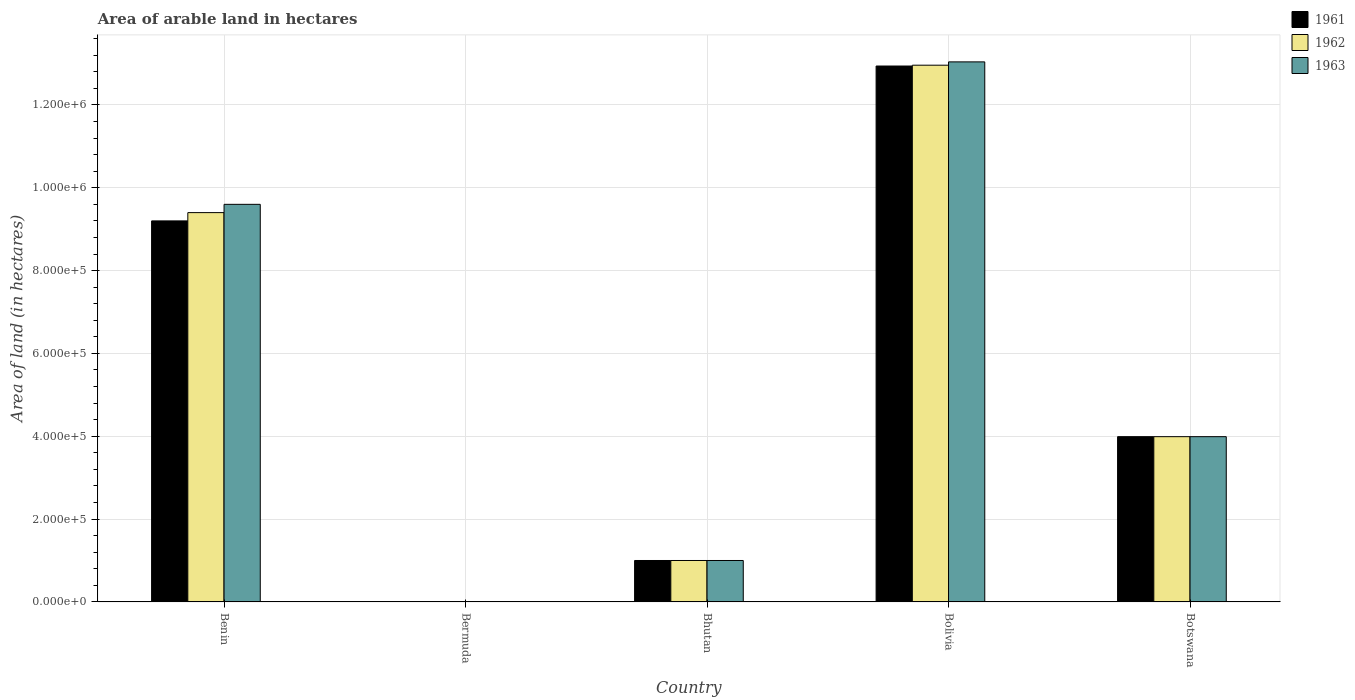How many different coloured bars are there?
Your answer should be compact. 3. How many groups of bars are there?
Make the answer very short. 5. Are the number of bars per tick equal to the number of legend labels?
Provide a short and direct response. Yes. Are the number of bars on each tick of the X-axis equal?
Your response must be concise. Yes. How many bars are there on the 1st tick from the left?
Your answer should be very brief. 3. What is the label of the 2nd group of bars from the left?
Give a very brief answer. Bermuda. In how many cases, is the number of bars for a given country not equal to the number of legend labels?
Keep it short and to the point. 0. What is the total arable land in 1963 in Bermuda?
Your response must be concise. 300. Across all countries, what is the maximum total arable land in 1961?
Offer a very short reply. 1.29e+06. In which country was the total arable land in 1962 maximum?
Offer a terse response. Bolivia. In which country was the total arable land in 1961 minimum?
Make the answer very short. Bermuda. What is the total total arable land in 1963 in the graph?
Provide a succinct answer. 2.76e+06. What is the difference between the total arable land in 1961 in Bhutan and that in Bolivia?
Ensure brevity in your answer.  -1.19e+06. What is the difference between the total arable land in 1962 in Bermuda and the total arable land in 1961 in Bolivia?
Ensure brevity in your answer.  -1.29e+06. What is the average total arable land in 1963 per country?
Provide a succinct answer. 5.53e+05. What is the difference between the total arable land of/in 1961 and total arable land of/in 1962 in Botswana?
Your answer should be very brief. 0. In how many countries, is the total arable land in 1963 greater than 1080000 hectares?
Give a very brief answer. 1. What is the ratio of the total arable land in 1963 in Bhutan to that in Bolivia?
Your response must be concise. 0.08. Is the total arable land in 1961 in Benin less than that in Bhutan?
Ensure brevity in your answer.  No. What is the difference between the highest and the second highest total arable land in 1963?
Ensure brevity in your answer.  3.44e+05. What is the difference between the highest and the lowest total arable land in 1962?
Your answer should be compact. 1.30e+06. What does the 3rd bar from the left in Bermuda represents?
Your response must be concise. 1963. What does the 3rd bar from the right in Bolivia represents?
Your response must be concise. 1961. Is it the case that in every country, the sum of the total arable land in 1962 and total arable land in 1961 is greater than the total arable land in 1963?
Your answer should be very brief. Yes. How many bars are there?
Your answer should be compact. 15. What is the difference between two consecutive major ticks on the Y-axis?
Your answer should be very brief. 2.00e+05. Does the graph contain grids?
Your answer should be compact. Yes. Where does the legend appear in the graph?
Give a very brief answer. Top right. What is the title of the graph?
Offer a terse response. Area of arable land in hectares. Does "2011" appear as one of the legend labels in the graph?
Ensure brevity in your answer.  No. What is the label or title of the Y-axis?
Offer a very short reply. Area of land (in hectares). What is the Area of land (in hectares) in 1961 in Benin?
Provide a short and direct response. 9.20e+05. What is the Area of land (in hectares) in 1962 in Benin?
Your response must be concise. 9.40e+05. What is the Area of land (in hectares) of 1963 in Benin?
Your response must be concise. 9.60e+05. What is the Area of land (in hectares) in 1962 in Bermuda?
Your answer should be very brief. 300. What is the Area of land (in hectares) of 1963 in Bermuda?
Your answer should be compact. 300. What is the Area of land (in hectares) of 1962 in Bhutan?
Keep it short and to the point. 1.00e+05. What is the Area of land (in hectares) of 1961 in Bolivia?
Keep it short and to the point. 1.29e+06. What is the Area of land (in hectares) in 1962 in Bolivia?
Make the answer very short. 1.30e+06. What is the Area of land (in hectares) in 1963 in Bolivia?
Make the answer very short. 1.30e+06. What is the Area of land (in hectares) of 1961 in Botswana?
Keep it short and to the point. 3.99e+05. What is the Area of land (in hectares) of 1962 in Botswana?
Keep it short and to the point. 3.99e+05. What is the Area of land (in hectares) of 1963 in Botswana?
Your answer should be very brief. 3.99e+05. Across all countries, what is the maximum Area of land (in hectares) in 1961?
Provide a short and direct response. 1.29e+06. Across all countries, what is the maximum Area of land (in hectares) of 1962?
Your response must be concise. 1.30e+06. Across all countries, what is the maximum Area of land (in hectares) in 1963?
Provide a short and direct response. 1.30e+06. Across all countries, what is the minimum Area of land (in hectares) in 1962?
Keep it short and to the point. 300. Across all countries, what is the minimum Area of land (in hectares) of 1963?
Provide a succinct answer. 300. What is the total Area of land (in hectares) in 1961 in the graph?
Ensure brevity in your answer.  2.71e+06. What is the total Area of land (in hectares) of 1962 in the graph?
Give a very brief answer. 2.74e+06. What is the total Area of land (in hectares) of 1963 in the graph?
Offer a very short reply. 2.76e+06. What is the difference between the Area of land (in hectares) in 1961 in Benin and that in Bermuda?
Make the answer very short. 9.20e+05. What is the difference between the Area of land (in hectares) of 1962 in Benin and that in Bermuda?
Provide a short and direct response. 9.40e+05. What is the difference between the Area of land (in hectares) in 1963 in Benin and that in Bermuda?
Provide a short and direct response. 9.60e+05. What is the difference between the Area of land (in hectares) in 1961 in Benin and that in Bhutan?
Your response must be concise. 8.20e+05. What is the difference between the Area of land (in hectares) of 1962 in Benin and that in Bhutan?
Keep it short and to the point. 8.40e+05. What is the difference between the Area of land (in hectares) of 1963 in Benin and that in Bhutan?
Offer a very short reply. 8.60e+05. What is the difference between the Area of land (in hectares) in 1961 in Benin and that in Bolivia?
Ensure brevity in your answer.  -3.74e+05. What is the difference between the Area of land (in hectares) in 1962 in Benin and that in Bolivia?
Your answer should be compact. -3.56e+05. What is the difference between the Area of land (in hectares) of 1963 in Benin and that in Bolivia?
Keep it short and to the point. -3.44e+05. What is the difference between the Area of land (in hectares) of 1961 in Benin and that in Botswana?
Give a very brief answer. 5.21e+05. What is the difference between the Area of land (in hectares) of 1962 in Benin and that in Botswana?
Keep it short and to the point. 5.41e+05. What is the difference between the Area of land (in hectares) of 1963 in Benin and that in Botswana?
Your answer should be very brief. 5.61e+05. What is the difference between the Area of land (in hectares) in 1961 in Bermuda and that in Bhutan?
Offer a very short reply. -9.96e+04. What is the difference between the Area of land (in hectares) in 1962 in Bermuda and that in Bhutan?
Provide a succinct answer. -9.97e+04. What is the difference between the Area of land (in hectares) in 1963 in Bermuda and that in Bhutan?
Offer a very short reply. -9.97e+04. What is the difference between the Area of land (in hectares) of 1961 in Bermuda and that in Bolivia?
Offer a very short reply. -1.29e+06. What is the difference between the Area of land (in hectares) of 1962 in Bermuda and that in Bolivia?
Your answer should be very brief. -1.30e+06. What is the difference between the Area of land (in hectares) in 1963 in Bermuda and that in Bolivia?
Your response must be concise. -1.30e+06. What is the difference between the Area of land (in hectares) of 1961 in Bermuda and that in Botswana?
Keep it short and to the point. -3.99e+05. What is the difference between the Area of land (in hectares) in 1962 in Bermuda and that in Botswana?
Offer a very short reply. -3.99e+05. What is the difference between the Area of land (in hectares) in 1963 in Bermuda and that in Botswana?
Provide a succinct answer. -3.99e+05. What is the difference between the Area of land (in hectares) in 1961 in Bhutan and that in Bolivia?
Your response must be concise. -1.19e+06. What is the difference between the Area of land (in hectares) in 1962 in Bhutan and that in Bolivia?
Make the answer very short. -1.20e+06. What is the difference between the Area of land (in hectares) of 1963 in Bhutan and that in Bolivia?
Make the answer very short. -1.20e+06. What is the difference between the Area of land (in hectares) in 1961 in Bhutan and that in Botswana?
Your answer should be very brief. -2.99e+05. What is the difference between the Area of land (in hectares) in 1962 in Bhutan and that in Botswana?
Your answer should be very brief. -2.99e+05. What is the difference between the Area of land (in hectares) of 1963 in Bhutan and that in Botswana?
Your response must be concise. -2.99e+05. What is the difference between the Area of land (in hectares) of 1961 in Bolivia and that in Botswana?
Your response must be concise. 8.95e+05. What is the difference between the Area of land (in hectares) of 1962 in Bolivia and that in Botswana?
Give a very brief answer. 8.97e+05. What is the difference between the Area of land (in hectares) of 1963 in Bolivia and that in Botswana?
Offer a terse response. 9.05e+05. What is the difference between the Area of land (in hectares) in 1961 in Benin and the Area of land (in hectares) in 1962 in Bermuda?
Give a very brief answer. 9.20e+05. What is the difference between the Area of land (in hectares) of 1961 in Benin and the Area of land (in hectares) of 1963 in Bermuda?
Keep it short and to the point. 9.20e+05. What is the difference between the Area of land (in hectares) of 1962 in Benin and the Area of land (in hectares) of 1963 in Bermuda?
Ensure brevity in your answer.  9.40e+05. What is the difference between the Area of land (in hectares) of 1961 in Benin and the Area of land (in hectares) of 1962 in Bhutan?
Ensure brevity in your answer.  8.20e+05. What is the difference between the Area of land (in hectares) in 1961 in Benin and the Area of land (in hectares) in 1963 in Bhutan?
Make the answer very short. 8.20e+05. What is the difference between the Area of land (in hectares) of 1962 in Benin and the Area of land (in hectares) of 1963 in Bhutan?
Provide a succinct answer. 8.40e+05. What is the difference between the Area of land (in hectares) in 1961 in Benin and the Area of land (in hectares) in 1962 in Bolivia?
Provide a short and direct response. -3.76e+05. What is the difference between the Area of land (in hectares) of 1961 in Benin and the Area of land (in hectares) of 1963 in Bolivia?
Make the answer very short. -3.84e+05. What is the difference between the Area of land (in hectares) in 1962 in Benin and the Area of land (in hectares) in 1963 in Bolivia?
Make the answer very short. -3.64e+05. What is the difference between the Area of land (in hectares) of 1961 in Benin and the Area of land (in hectares) of 1962 in Botswana?
Offer a terse response. 5.21e+05. What is the difference between the Area of land (in hectares) in 1961 in Benin and the Area of land (in hectares) in 1963 in Botswana?
Your answer should be compact. 5.21e+05. What is the difference between the Area of land (in hectares) in 1962 in Benin and the Area of land (in hectares) in 1963 in Botswana?
Provide a succinct answer. 5.41e+05. What is the difference between the Area of land (in hectares) in 1961 in Bermuda and the Area of land (in hectares) in 1962 in Bhutan?
Your answer should be very brief. -9.96e+04. What is the difference between the Area of land (in hectares) of 1961 in Bermuda and the Area of land (in hectares) of 1963 in Bhutan?
Your answer should be compact. -9.96e+04. What is the difference between the Area of land (in hectares) in 1962 in Bermuda and the Area of land (in hectares) in 1963 in Bhutan?
Make the answer very short. -9.97e+04. What is the difference between the Area of land (in hectares) of 1961 in Bermuda and the Area of land (in hectares) of 1962 in Bolivia?
Your answer should be compact. -1.30e+06. What is the difference between the Area of land (in hectares) in 1961 in Bermuda and the Area of land (in hectares) in 1963 in Bolivia?
Offer a very short reply. -1.30e+06. What is the difference between the Area of land (in hectares) in 1962 in Bermuda and the Area of land (in hectares) in 1963 in Bolivia?
Ensure brevity in your answer.  -1.30e+06. What is the difference between the Area of land (in hectares) in 1961 in Bermuda and the Area of land (in hectares) in 1962 in Botswana?
Offer a very short reply. -3.99e+05. What is the difference between the Area of land (in hectares) of 1961 in Bermuda and the Area of land (in hectares) of 1963 in Botswana?
Make the answer very short. -3.99e+05. What is the difference between the Area of land (in hectares) in 1962 in Bermuda and the Area of land (in hectares) in 1963 in Botswana?
Offer a terse response. -3.99e+05. What is the difference between the Area of land (in hectares) in 1961 in Bhutan and the Area of land (in hectares) in 1962 in Bolivia?
Your response must be concise. -1.20e+06. What is the difference between the Area of land (in hectares) in 1961 in Bhutan and the Area of land (in hectares) in 1963 in Bolivia?
Offer a terse response. -1.20e+06. What is the difference between the Area of land (in hectares) of 1962 in Bhutan and the Area of land (in hectares) of 1963 in Bolivia?
Your response must be concise. -1.20e+06. What is the difference between the Area of land (in hectares) in 1961 in Bhutan and the Area of land (in hectares) in 1962 in Botswana?
Offer a very short reply. -2.99e+05. What is the difference between the Area of land (in hectares) in 1961 in Bhutan and the Area of land (in hectares) in 1963 in Botswana?
Your answer should be compact. -2.99e+05. What is the difference between the Area of land (in hectares) of 1962 in Bhutan and the Area of land (in hectares) of 1963 in Botswana?
Offer a very short reply. -2.99e+05. What is the difference between the Area of land (in hectares) in 1961 in Bolivia and the Area of land (in hectares) in 1962 in Botswana?
Give a very brief answer. 8.95e+05. What is the difference between the Area of land (in hectares) in 1961 in Bolivia and the Area of land (in hectares) in 1963 in Botswana?
Provide a short and direct response. 8.95e+05. What is the difference between the Area of land (in hectares) in 1962 in Bolivia and the Area of land (in hectares) in 1963 in Botswana?
Make the answer very short. 8.97e+05. What is the average Area of land (in hectares) in 1961 per country?
Provide a succinct answer. 5.43e+05. What is the average Area of land (in hectares) of 1962 per country?
Offer a very short reply. 5.47e+05. What is the average Area of land (in hectares) in 1963 per country?
Provide a succinct answer. 5.53e+05. What is the difference between the Area of land (in hectares) in 1962 and Area of land (in hectares) in 1963 in Benin?
Offer a very short reply. -2.00e+04. What is the difference between the Area of land (in hectares) of 1961 and Area of land (in hectares) of 1963 in Bermuda?
Provide a short and direct response. 100. What is the difference between the Area of land (in hectares) of 1962 and Area of land (in hectares) of 1963 in Bermuda?
Your answer should be very brief. 0. What is the difference between the Area of land (in hectares) of 1961 and Area of land (in hectares) of 1963 in Bhutan?
Provide a short and direct response. 0. What is the difference between the Area of land (in hectares) of 1962 and Area of land (in hectares) of 1963 in Bhutan?
Your response must be concise. 0. What is the difference between the Area of land (in hectares) of 1961 and Area of land (in hectares) of 1962 in Bolivia?
Your answer should be very brief. -2000. What is the difference between the Area of land (in hectares) in 1961 and Area of land (in hectares) in 1963 in Bolivia?
Your answer should be compact. -10000. What is the difference between the Area of land (in hectares) in 1962 and Area of land (in hectares) in 1963 in Bolivia?
Offer a very short reply. -8000. What is the difference between the Area of land (in hectares) of 1961 and Area of land (in hectares) of 1962 in Botswana?
Your response must be concise. 0. What is the ratio of the Area of land (in hectares) of 1961 in Benin to that in Bermuda?
Make the answer very short. 2300. What is the ratio of the Area of land (in hectares) of 1962 in Benin to that in Bermuda?
Provide a short and direct response. 3133.33. What is the ratio of the Area of land (in hectares) in 1963 in Benin to that in Bermuda?
Give a very brief answer. 3200. What is the ratio of the Area of land (in hectares) in 1962 in Benin to that in Bhutan?
Give a very brief answer. 9.4. What is the ratio of the Area of land (in hectares) in 1963 in Benin to that in Bhutan?
Keep it short and to the point. 9.6. What is the ratio of the Area of land (in hectares) of 1961 in Benin to that in Bolivia?
Provide a succinct answer. 0.71. What is the ratio of the Area of land (in hectares) in 1962 in Benin to that in Bolivia?
Provide a short and direct response. 0.73. What is the ratio of the Area of land (in hectares) of 1963 in Benin to that in Bolivia?
Offer a very short reply. 0.74. What is the ratio of the Area of land (in hectares) in 1961 in Benin to that in Botswana?
Provide a short and direct response. 2.31. What is the ratio of the Area of land (in hectares) in 1962 in Benin to that in Botswana?
Provide a short and direct response. 2.36. What is the ratio of the Area of land (in hectares) of 1963 in Benin to that in Botswana?
Your response must be concise. 2.41. What is the ratio of the Area of land (in hectares) in 1961 in Bermuda to that in Bhutan?
Keep it short and to the point. 0. What is the ratio of the Area of land (in hectares) in 1962 in Bermuda to that in Bhutan?
Offer a terse response. 0. What is the ratio of the Area of land (in hectares) of 1963 in Bermuda to that in Bhutan?
Offer a terse response. 0. What is the ratio of the Area of land (in hectares) of 1961 in Bermuda to that in Bolivia?
Make the answer very short. 0. What is the ratio of the Area of land (in hectares) in 1962 in Bermuda to that in Bolivia?
Your answer should be compact. 0. What is the ratio of the Area of land (in hectares) of 1963 in Bermuda to that in Bolivia?
Offer a terse response. 0. What is the ratio of the Area of land (in hectares) of 1962 in Bermuda to that in Botswana?
Your answer should be very brief. 0. What is the ratio of the Area of land (in hectares) in 1963 in Bermuda to that in Botswana?
Make the answer very short. 0. What is the ratio of the Area of land (in hectares) of 1961 in Bhutan to that in Bolivia?
Your answer should be very brief. 0.08. What is the ratio of the Area of land (in hectares) in 1962 in Bhutan to that in Bolivia?
Make the answer very short. 0.08. What is the ratio of the Area of land (in hectares) of 1963 in Bhutan to that in Bolivia?
Make the answer very short. 0.08. What is the ratio of the Area of land (in hectares) of 1961 in Bhutan to that in Botswana?
Your answer should be compact. 0.25. What is the ratio of the Area of land (in hectares) of 1962 in Bhutan to that in Botswana?
Give a very brief answer. 0.25. What is the ratio of the Area of land (in hectares) in 1963 in Bhutan to that in Botswana?
Provide a short and direct response. 0.25. What is the ratio of the Area of land (in hectares) in 1961 in Bolivia to that in Botswana?
Your response must be concise. 3.24. What is the ratio of the Area of land (in hectares) in 1962 in Bolivia to that in Botswana?
Give a very brief answer. 3.25. What is the ratio of the Area of land (in hectares) in 1963 in Bolivia to that in Botswana?
Your response must be concise. 3.27. What is the difference between the highest and the second highest Area of land (in hectares) of 1961?
Provide a short and direct response. 3.74e+05. What is the difference between the highest and the second highest Area of land (in hectares) in 1962?
Your answer should be compact. 3.56e+05. What is the difference between the highest and the second highest Area of land (in hectares) of 1963?
Provide a succinct answer. 3.44e+05. What is the difference between the highest and the lowest Area of land (in hectares) in 1961?
Your answer should be very brief. 1.29e+06. What is the difference between the highest and the lowest Area of land (in hectares) in 1962?
Provide a succinct answer. 1.30e+06. What is the difference between the highest and the lowest Area of land (in hectares) in 1963?
Provide a succinct answer. 1.30e+06. 